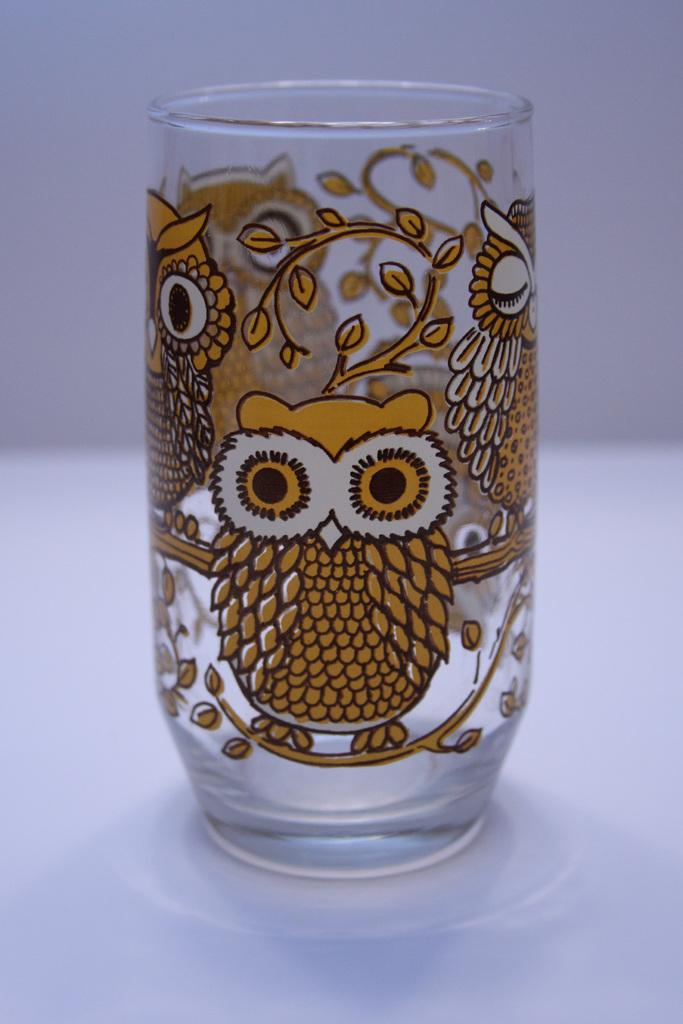What is located in the center of the image? There is a table in the center of the image. What is placed on the table? There is a glass and a saucer on the table. Can you describe the glass? The glass has a design on it. What can be seen in the background of the image? There is a wall in the background of the image. What type of discussion is taking place at the table in the image? There is no discussion taking place at the table in the image; it only shows a glass, a saucer, and a table. How many kittens are sitting on the table in the image? There are no kittens present in the image. 